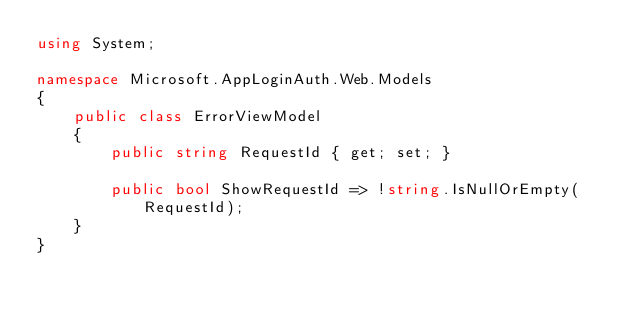Convert code to text. <code><loc_0><loc_0><loc_500><loc_500><_C#_>using System;

namespace Microsoft.AppLoginAuth.Web.Models
{
    public class ErrorViewModel
    {
        public string RequestId { get; set; }

        public bool ShowRequestId => !string.IsNullOrEmpty(RequestId);
    }
}
</code> 